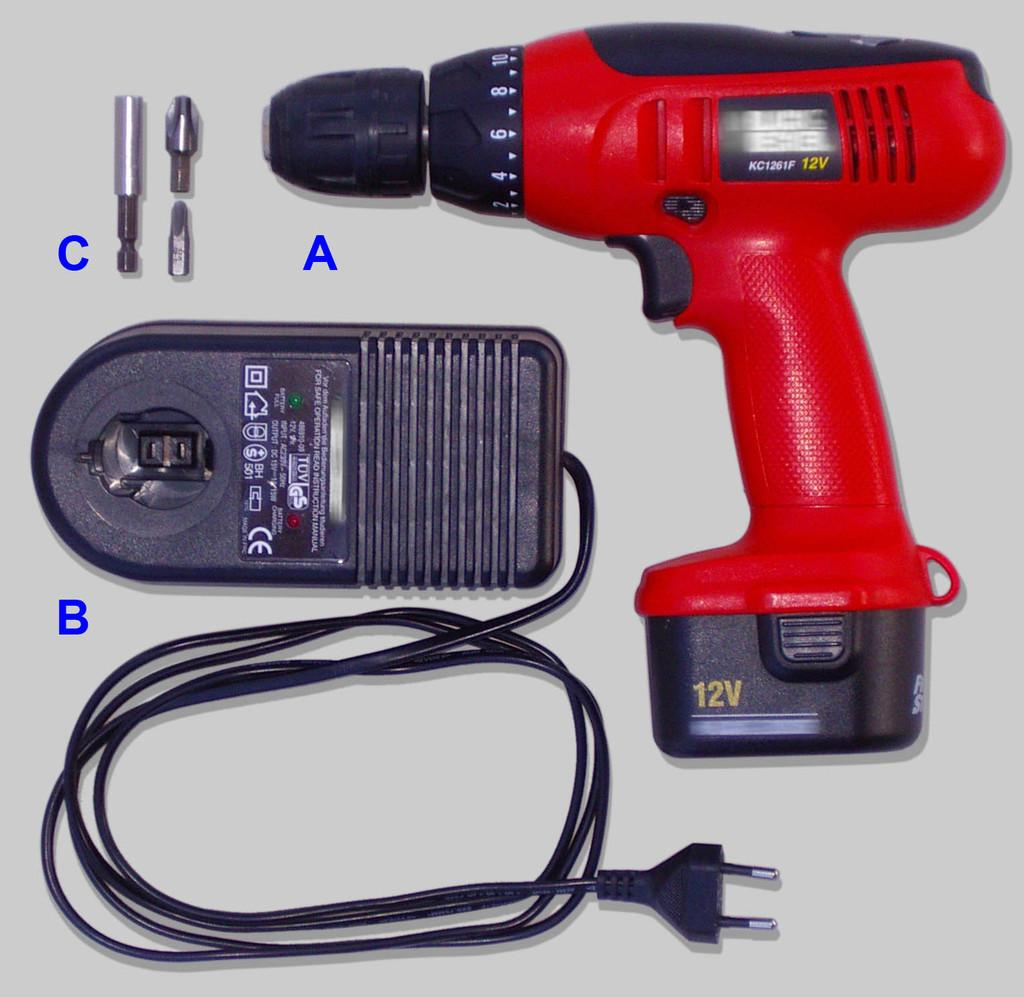What is the main object in the image? There is a drilling machine in the image. Are there any other objects present in the image? Yes, there are other objects in the image. What is the color of the surface on which the objects are placed? The surface on which the objects are placed is white. What type of letters are being exchanged between the warring factions in the image? There is no mention of war or letters in the image; it features a drilling machine and other objects on a white surface. Can you see a pin holding the drilling machine in place in the image? There is no pin visible in the image; the drilling machine and other objects are simply placed on the white surface. 